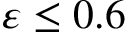Convert formula to latex. <formula><loc_0><loc_0><loc_500><loc_500>\varepsilon \leq 0 . 6</formula> 